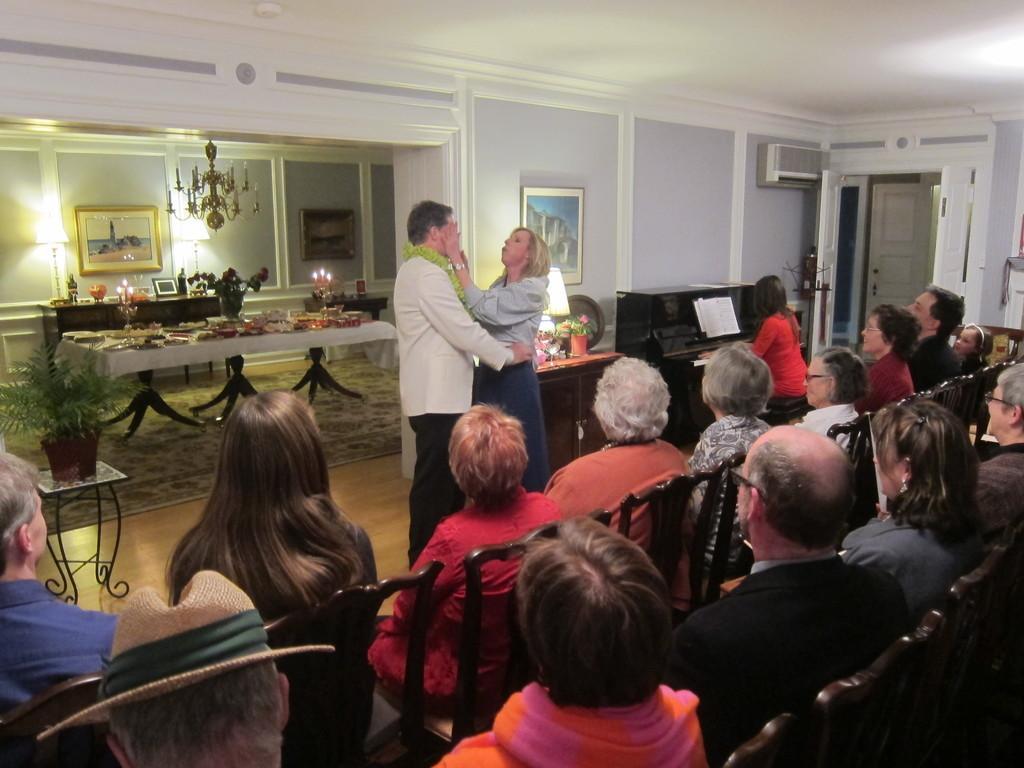In one or two sentences, can you explain what this image depicts? In this picture I can observe some people sitting on the chairs. There are men and women in this picture. In front of them there is a couple standing on the floor. On the left side I can observe a table and a chandelier hanging to the ceiling. In the background I can observe some photo frames on the wall. 